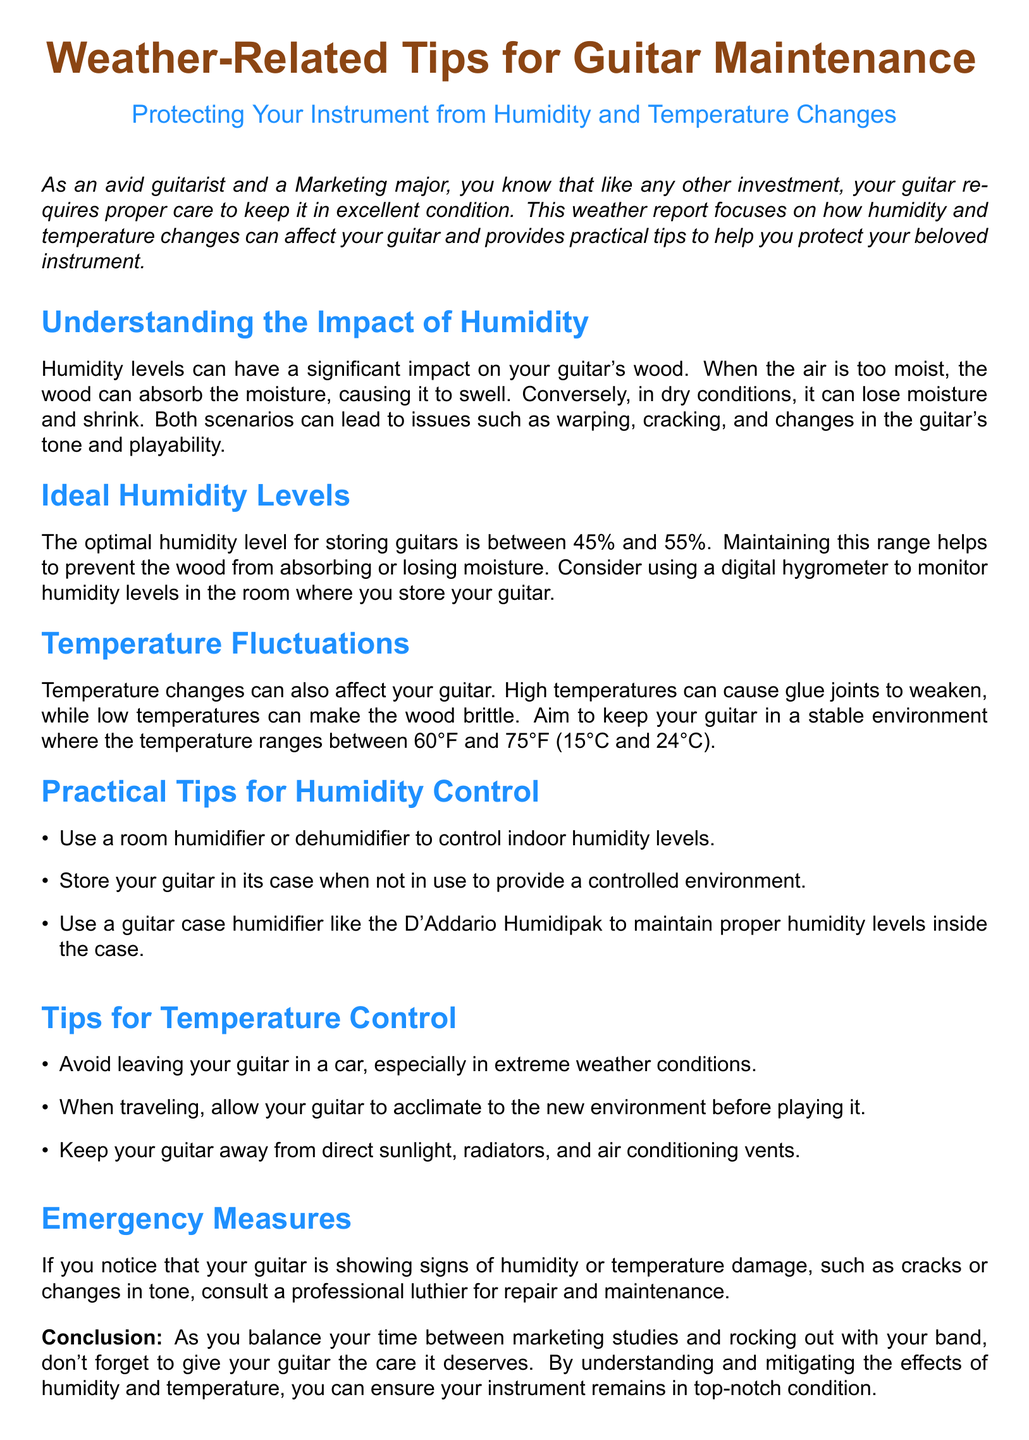What is the optimal humidity level for storing guitars? The document states that the optimal humidity level for storing guitars is between 45% and 55%.
Answer: 45% and 55% What can occur if wood loses moisture? The document mentions that when wood loses moisture, it can shrink, leading to issues like warping and cracking.
Answer: Warping and cracking What device can help monitor humidity levels? The document suggests using a digital hygrometer to monitor humidity levels.
Answer: Digital hygrometer What is the ideal temperature range for storing guitars? The document advises keeping the temperature between 60°F and 75°F (15°C and 24°C).
Answer: 60°F and 75°F What should you avoid doing with your guitar in extreme weather? The document cautions against leaving your guitar in a car during extreme weather conditions.
Answer: Leaving your guitar in a car What is one method for controlling humidity inside a guitar case? According to the document, using a guitar case humidifier like the D'Addario Humidipak can maintain proper humidity levels.
Answer: D'Addario Humidipak Who should you consult if your guitar shows signs of damage? The document recommends consulting a professional luthier for repairs and maintenance if you notice damage.
Answer: Professional luthier What is a practical tip to help maintain a stable temperature for your guitar? The document suggests keeping your guitar away from direct sunlight, radiators, and air conditioning vents.
Answer: Away from direct sunlight What type of report is this document categorized as? The document is categorized as a weather report focusing on guitar maintenance.
Answer: Weather report 